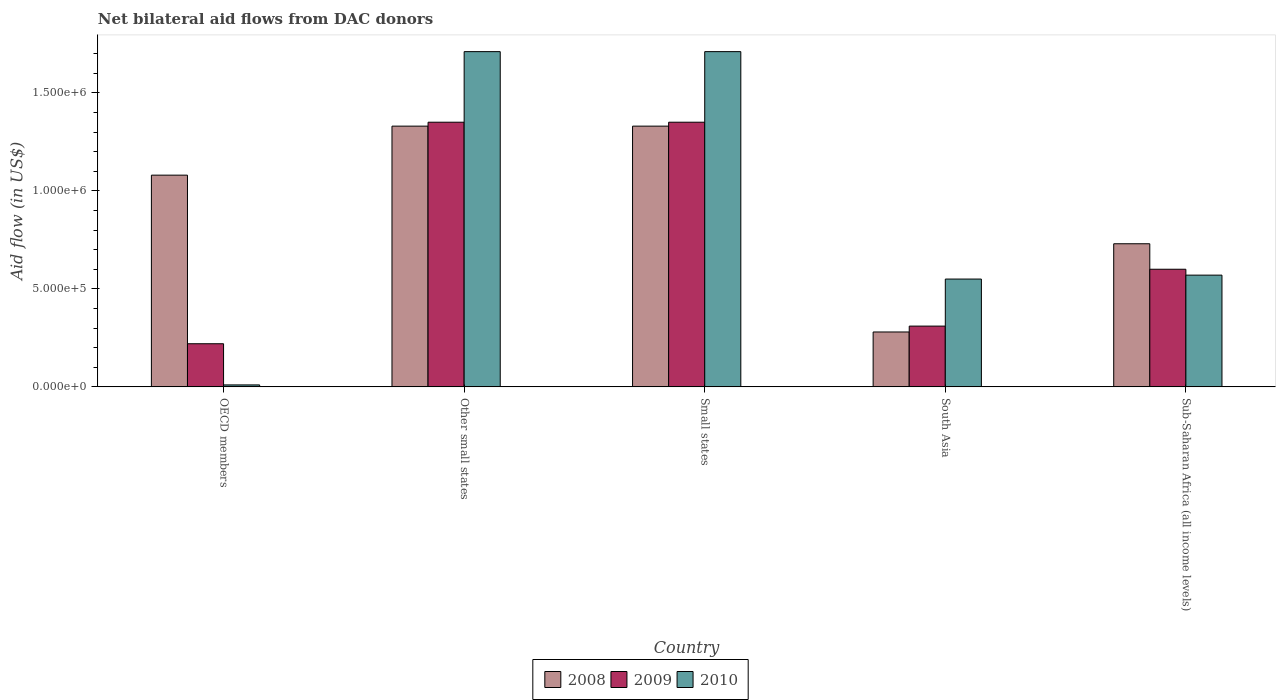How many different coloured bars are there?
Ensure brevity in your answer.  3. How many groups of bars are there?
Keep it short and to the point. 5. Are the number of bars per tick equal to the number of legend labels?
Make the answer very short. Yes. What is the label of the 2nd group of bars from the left?
Keep it short and to the point. Other small states. In how many cases, is the number of bars for a given country not equal to the number of legend labels?
Ensure brevity in your answer.  0. What is the net bilateral aid flow in 2010 in Small states?
Ensure brevity in your answer.  1.71e+06. Across all countries, what is the maximum net bilateral aid flow in 2009?
Your response must be concise. 1.35e+06. Across all countries, what is the minimum net bilateral aid flow in 2008?
Make the answer very short. 2.80e+05. In which country was the net bilateral aid flow in 2008 maximum?
Your response must be concise. Other small states. In which country was the net bilateral aid flow in 2008 minimum?
Offer a terse response. South Asia. What is the total net bilateral aid flow in 2008 in the graph?
Provide a succinct answer. 4.75e+06. What is the difference between the net bilateral aid flow in 2009 in Small states and that in South Asia?
Your answer should be compact. 1.04e+06. What is the difference between the net bilateral aid flow in 2008 in OECD members and the net bilateral aid flow in 2009 in Other small states?
Provide a short and direct response. -2.70e+05. What is the average net bilateral aid flow in 2009 per country?
Your answer should be compact. 7.66e+05. What is the difference between the net bilateral aid flow of/in 2010 and net bilateral aid flow of/in 2008 in OECD members?
Offer a terse response. -1.07e+06. What is the ratio of the net bilateral aid flow in 2009 in Small states to that in Sub-Saharan Africa (all income levels)?
Provide a short and direct response. 2.25. Is the net bilateral aid flow in 2010 in Small states less than that in South Asia?
Give a very brief answer. No. What is the difference between the highest and the second highest net bilateral aid flow in 2008?
Give a very brief answer. 2.50e+05. What is the difference between the highest and the lowest net bilateral aid flow in 2008?
Offer a very short reply. 1.05e+06. What does the 1st bar from the right in Sub-Saharan Africa (all income levels) represents?
Offer a very short reply. 2010. Is it the case that in every country, the sum of the net bilateral aid flow in 2010 and net bilateral aid flow in 2008 is greater than the net bilateral aid flow in 2009?
Your answer should be very brief. Yes. How many bars are there?
Provide a short and direct response. 15. Are all the bars in the graph horizontal?
Keep it short and to the point. No. How many countries are there in the graph?
Provide a short and direct response. 5. What is the difference between two consecutive major ticks on the Y-axis?
Make the answer very short. 5.00e+05. Are the values on the major ticks of Y-axis written in scientific E-notation?
Provide a short and direct response. Yes. Does the graph contain any zero values?
Your response must be concise. No. Where does the legend appear in the graph?
Your answer should be very brief. Bottom center. What is the title of the graph?
Give a very brief answer. Net bilateral aid flows from DAC donors. Does "1982" appear as one of the legend labels in the graph?
Provide a short and direct response. No. What is the label or title of the Y-axis?
Your answer should be compact. Aid flow (in US$). What is the Aid flow (in US$) of 2008 in OECD members?
Provide a short and direct response. 1.08e+06. What is the Aid flow (in US$) of 2009 in OECD members?
Make the answer very short. 2.20e+05. What is the Aid flow (in US$) in 2008 in Other small states?
Make the answer very short. 1.33e+06. What is the Aid flow (in US$) in 2009 in Other small states?
Ensure brevity in your answer.  1.35e+06. What is the Aid flow (in US$) in 2010 in Other small states?
Provide a short and direct response. 1.71e+06. What is the Aid flow (in US$) of 2008 in Small states?
Make the answer very short. 1.33e+06. What is the Aid flow (in US$) in 2009 in Small states?
Give a very brief answer. 1.35e+06. What is the Aid flow (in US$) in 2010 in Small states?
Offer a very short reply. 1.71e+06. What is the Aid flow (in US$) in 2008 in Sub-Saharan Africa (all income levels)?
Give a very brief answer. 7.30e+05. What is the Aid flow (in US$) in 2010 in Sub-Saharan Africa (all income levels)?
Give a very brief answer. 5.70e+05. Across all countries, what is the maximum Aid flow (in US$) in 2008?
Your answer should be compact. 1.33e+06. Across all countries, what is the maximum Aid flow (in US$) of 2009?
Your response must be concise. 1.35e+06. Across all countries, what is the maximum Aid flow (in US$) of 2010?
Make the answer very short. 1.71e+06. Across all countries, what is the minimum Aid flow (in US$) in 2008?
Give a very brief answer. 2.80e+05. Across all countries, what is the minimum Aid flow (in US$) in 2010?
Provide a succinct answer. 10000. What is the total Aid flow (in US$) in 2008 in the graph?
Keep it short and to the point. 4.75e+06. What is the total Aid flow (in US$) in 2009 in the graph?
Your answer should be very brief. 3.83e+06. What is the total Aid flow (in US$) in 2010 in the graph?
Ensure brevity in your answer.  4.55e+06. What is the difference between the Aid flow (in US$) in 2008 in OECD members and that in Other small states?
Offer a terse response. -2.50e+05. What is the difference between the Aid flow (in US$) in 2009 in OECD members and that in Other small states?
Your answer should be very brief. -1.13e+06. What is the difference between the Aid flow (in US$) in 2010 in OECD members and that in Other small states?
Provide a succinct answer. -1.70e+06. What is the difference between the Aid flow (in US$) in 2008 in OECD members and that in Small states?
Ensure brevity in your answer.  -2.50e+05. What is the difference between the Aid flow (in US$) in 2009 in OECD members and that in Small states?
Give a very brief answer. -1.13e+06. What is the difference between the Aid flow (in US$) in 2010 in OECD members and that in Small states?
Provide a succinct answer. -1.70e+06. What is the difference between the Aid flow (in US$) of 2009 in OECD members and that in South Asia?
Ensure brevity in your answer.  -9.00e+04. What is the difference between the Aid flow (in US$) in 2010 in OECD members and that in South Asia?
Give a very brief answer. -5.40e+05. What is the difference between the Aid flow (in US$) in 2009 in OECD members and that in Sub-Saharan Africa (all income levels)?
Your answer should be compact. -3.80e+05. What is the difference between the Aid flow (in US$) of 2010 in OECD members and that in Sub-Saharan Africa (all income levels)?
Your answer should be compact. -5.60e+05. What is the difference between the Aid flow (in US$) in 2008 in Other small states and that in Small states?
Provide a succinct answer. 0. What is the difference between the Aid flow (in US$) of 2010 in Other small states and that in Small states?
Your answer should be very brief. 0. What is the difference between the Aid flow (in US$) in 2008 in Other small states and that in South Asia?
Provide a short and direct response. 1.05e+06. What is the difference between the Aid flow (in US$) in 2009 in Other small states and that in South Asia?
Provide a succinct answer. 1.04e+06. What is the difference between the Aid flow (in US$) in 2010 in Other small states and that in South Asia?
Offer a very short reply. 1.16e+06. What is the difference between the Aid flow (in US$) of 2009 in Other small states and that in Sub-Saharan Africa (all income levels)?
Give a very brief answer. 7.50e+05. What is the difference between the Aid flow (in US$) of 2010 in Other small states and that in Sub-Saharan Africa (all income levels)?
Your answer should be compact. 1.14e+06. What is the difference between the Aid flow (in US$) in 2008 in Small states and that in South Asia?
Offer a very short reply. 1.05e+06. What is the difference between the Aid flow (in US$) of 2009 in Small states and that in South Asia?
Your answer should be compact. 1.04e+06. What is the difference between the Aid flow (in US$) of 2010 in Small states and that in South Asia?
Give a very brief answer. 1.16e+06. What is the difference between the Aid flow (in US$) of 2008 in Small states and that in Sub-Saharan Africa (all income levels)?
Make the answer very short. 6.00e+05. What is the difference between the Aid flow (in US$) in 2009 in Small states and that in Sub-Saharan Africa (all income levels)?
Keep it short and to the point. 7.50e+05. What is the difference between the Aid flow (in US$) in 2010 in Small states and that in Sub-Saharan Africa (all income levels)?
Ensure brevity in your answer.  1.14e+06. What is the difference between the Aid flow (in US$) of 2008 in South Asia and that in Sub-Saharan Africa (all income levels)?
Your response must be concise. -4.50e+05. What is the difference between the Aid flow (in US$) of 2008 in OECD members and the Aid flow (in US$) of 2010 in Other small states?
Your response must be concise. -6.30e+05. What is the difference between the Aid flow (in US$) in 2009 in OECD members and the Aid flow (in US$) in 2010 in Other small states?
Offer a very short reply. -1.49e+06. What is the difference between the Aid flow (in US$) of 2008 in OECD members and the Aid flow (in US$) of 2010 in Small states?
Ensure brevity in your answer.  -6.30e+05. What is the difference between the Aid flow (in US$) in 2009 in OECD members and the Aid flow (in US$) in 2010 in Small states?
Offer a terse response. -1.49e+06. What is the difference between the Aid flow (in US$) in 2008 in OECD members and the Aid flow (in US$) in 2009 in South Asia?
Your response must be concise. 7.70e+05. What is the difference between the Aid flow (in US$) in 2008 in OECD members and the Aid flow (in US$) in 2010 in South Asia?
Your answer should be compact. 5.30e+05. What is the difference between the Aid flow (in US$) of 2009 in OECD members and the Aid flow (in US$) of 2010 in South Asia?
Give a very brief answer. -3.30e+05. What is the difference between the Aid flow (in US$) in 2008 in OECD members and the Aid flow (in US$) in 2010 in Sub-Saharan Africa (all income levels)?
Keep it short and to the point. 5.10e+05. What is the difference between the Aid flow (in US$) of 2009 in OECD members and the Aid flow (in US$) of 2010 in Sub-Saharan Africa (all income levels)?
Provide a succinct answer. -3.50e+05. What is the difference between the Aid flow (in US$) in 2008 in Other small states and the Aid flow (in US$) in 2010 in Small states?
Offer a terse response. -3.80e+05. What is the difference between the Aid flow (in US$) of 2009 in Other small states and the Aid flow (in US$) of 2010 in Small states?
Ensure brevity in your answer.  -3.60e+05. What is the difference between the Aid flow (in US$) in 2008 in Other small states and the Aid flow (in US$) in 2009 in South Asia?
Offer a very short reply. 1.02e+06. What is the difference between the Aid flow (in US$) in 2008 in Other small states and the Aid flow (in US$) in 2010 in South Asia?
Give a very brief answer. 7.80e+05. What is the difference between the Aid flow (in US$) in 2008 in Other small states and the Aid flow (in US$) in 2009 in Sub-Saharan Africa (all income levels)?
Your response must be concise. 7.30e+05. What is the difference between the Aid flow (in US$) in 2008 in Other small states and the Aid flow (in US$) in 2010 in Sub-Saharan Africa (all income levels)?
Give a very brief answer. 7.60e+05. What is the difference between the Aid flow (in US$) in 2009 in Other small states and the Aid flow (in US$) in 2010 in Sub-Saharan Africa (all income levels)?
Keep it short and to the point. 7.80e+05. What is the difference between the Aid flow (in US$) of 2008 in Small states and the Aid flow (in US$) of 2009 in South Asia?
Offer a terse response. 1.02e+06. What is the difference between the Aid flow (in US$) in 2008 in Small states and the Aid flow (in US$) in 2010 in South Asia?
Your answer should be compact. 7.80e+05. What is the difference between the Aid flow (in US$) of 2008 in Small states and the Aid flow (in US$) of 2009 in Sub-Saharan Africa (all income levels)?
Give a very brief answer. 7.30e+05. What is the difference between the Aid flow (in US$) of 2008 in Small states and the Aid flow (in US$) of 2010 in Sub-Saharan Africa (all income levels)?
Keep it short and to the point. 7.60e+05. What is the difference between the Aid flow (in US$) of 2009 in Small states and the Aid flow (in US$) of 2010 in Sub-Saharan Africa (all income levels)?
Your answer should be very brief. 7.80e+05. What is the difference between the Aid flow (in US$) in 2008 in South Asia and the Aid flow (in US$) in 2009 in Sub-Saharan Africa (all income levels)?
Your answer should be very brief. -3.20e+05. What is the difference between the Aid flow (in US$) of 2009 in South Asia and the Aid flow (in US$) of 2010 in Sub-Saharan Africa (all income levels)?
Your response must be concise. -2.60e+05. What is the average Aid flow (in US$) of 2008 per country?
Make the answer very short. 9.50e+05. What is the average Aid flow (in US$) of 2009 per country?
Your answer should be compact. 7.66e+05. What is the average Aid flow (in US$) in 2010 per country?
Give a very brief answer. 9.10e+05. What is the difference between the Aid flow (in US$) of 2008 and Aid flow (in US$) of 2009 in OECD members?
Provide a succinct answer. 8.60e+05. What is the difference between the Aid flow (in US$) of 2008 and Aid flow (in US$) of 2010 in OECD members?
Make the answer very short. 1.07e+06. What is the difference between the Aid flow (in US$) of 2008 and Aid flow (in US$) of 2010 in Other small states?
Make the answer very short. -3.80e+05. What is the difference between the Aid flow (in US$) in 2009 and Aid flow (in US$) in 2010 in Other small states?
Your answer should be very brief. -3.60e+05. What is the difference between the Aid flow (in US$) in 2008 and Aid flow (in US$) in 2010 in Small states?
Your answer should be very brief. -3.80e+05. What is the difference between the Aid flow (in US$) of 2009 and Aid flow (in US$) of 2010 in Small states?
Offer a very short reply. -3.60e+05. What is the difference between the Aid flow (in US$) in 2008 and Aid flow (in US$) in 2010 in South Asia?
Give a very brief answer. -2.70e+05. What is the difference between the Aid flow (in US$) of 2009 and Aid flow (in US$) of 2010 in South Asia?
Make the answer very short. -2.40e+05. What is the difference between the Aid flow (in US$) of 2008 and Aid flow (in US$) of 2009 in Sub-Saharan Africa (all income levels)?
Your answer should be very brief. 1.30e+05. What is the ratio of the Aid flow (in US$) in 2008 in OECD members to that in Other small states?
Your response must be concise. 0.81. What is the ratio of the Aid flow (in US$) in 2009 in OECD members to that in Other small states?
Your response must be concise. 0.16. What is the ratio of the Aid flow (in US$) in 2010 in OECD members to that in Other small states?
Keep it short and to the point. 0.01. What is the ratio of the Aid flow (in US$) of 2008 in OECD members to that in Small states?
Keep it short and to the point. 0.81. What is the ratio of the Aid flow (in US$) in 2009 in OECD members to that in Small states?
Your answer should be compact. 0.16. What is the ratio of the Aid flow (in US$) in 2010 in OECD members to that in Small states?
Offer a very short reply. 0.01. What is the ratio of the Aid flow (in US$) of 2008 in OECD members to that in South Asia?
Give a very brief answer. 3.86. What is the ratio of the Aid flow (in US$) of 2009 in OECD members to that in South Asia?
Provide a short and direct response. 0.71. What is the ratio of the Aid flow (in US$) of 2010 in OECD members to that in South Asia?
Offer a very short reply. 0.02. What is the ratio of the Aid flow (in US$) of 2008 in OECD members to that in Sub-Saharan Africa (all income levels)?
Provide a short and direct response. 1.48. What is the ratio of the Aid flow (in US$) in 2009 in OECD members to that in Sub-Saharan Africa (all income levels)?
Your response must be concise. 0.37. What is the ratio of the Aid flow (in US$) in 2010 in OECD members to that in Sub-Saharan Africa (all income levels)?
Make the answer very short. 0.02. What is the ratio of the Aid flow (in US$) in 2009 in Other small states to that in Small states?
Ensure brevity in your answer.  1. What is the ratio of the Aid flow (in US$) of 2008 in Other small states to that in South Asia?
Keep it short and to the point. 4.75. What is the ratio of the Aid flow (in US$) of 2009 in Other small states to that in South Asia?
Keep it short and to the point. 4.35. What is the ratio of the Aid flow (in US$) of 2010 in Other small states to that in South Asia?
Keep it short and to the point. 3.11. What is the ratio of the Aid flow (in US$) of 2008 in Other small states to that in Sub-Saharan Africa (all income levels)?
Ensure brevity in your answer.  1.82. What is the ratio of the Aid flow (in US$) of 2009 in Other small states to that in Sub-Saharan Africa (all income levels)?
Keep it short and to the point. 2.25. What is the ratio of the Aid flow (in US$) of 2010 in Other small states to that in Sub-Saharan Africa (all income levels)?
Provide a short and direct response. 3. What is the ratio of the Aid flow (in US$) in 2008 in Small states to that in South Asia?
Keep it short and to the point. 4.75. What is the ratio of the Aid flow (in US$) of 2009 in Small states to that in South Asia?
Your answer should be compact. 4.35. What is the ratio of the Aid flow (in US$) in 2010 in Small states to that in South Asia?
Your answer should be compact. 3.11. What is the ratio of the Aid flow (in US$) of 2008 in Small states to that in Sub-Saharan Africa (all income levels)?
Offer a very short reply. 1.82. What is the ratio of the Aid flow (in US$) of 2009 in Small states to that in Sub-Saharan Africa (all income levels)?
Your response must be concise. 2.25. What is the ratio of the Aid flow (in US$) of 2008 in South Asia to that in Sub-Saharan Africa (all income levels)?
Provide a succinct answer. 0.38. What is the ratio of the Aid flow (in US$) of 2009 in South Asia to that in Sub-Saharan Africa (all income levels)?
Your answer should be very brief. 0.52. What is the ratio of the Aid flow (in US$) in 2010 in South Asia to that in Sub-Saharan Africa (all income levels)?
Make the answer very short. 0.96. What is the difference between the highest and the second highest Aid flow (in US$) in 2009?
Keep it short and to the point. 0. What is the difference between the highest and the second highest Aid flow (in US$) of 2010?
Make the answer very short. 0. What is the difference between the highest and the lowest Aid flow (in US$) of 2008?
Provide a short and direct response. 1.05e+06. What is the difference between the highest and the lowest Aid flow (in US$) of 2009?
Ensure brevity in your answer.  1.13e+06. What is the difference between the highest and the lowest Aid flow (in US$) in 2010?
Your answer should be very brief. 1.70e+06. 